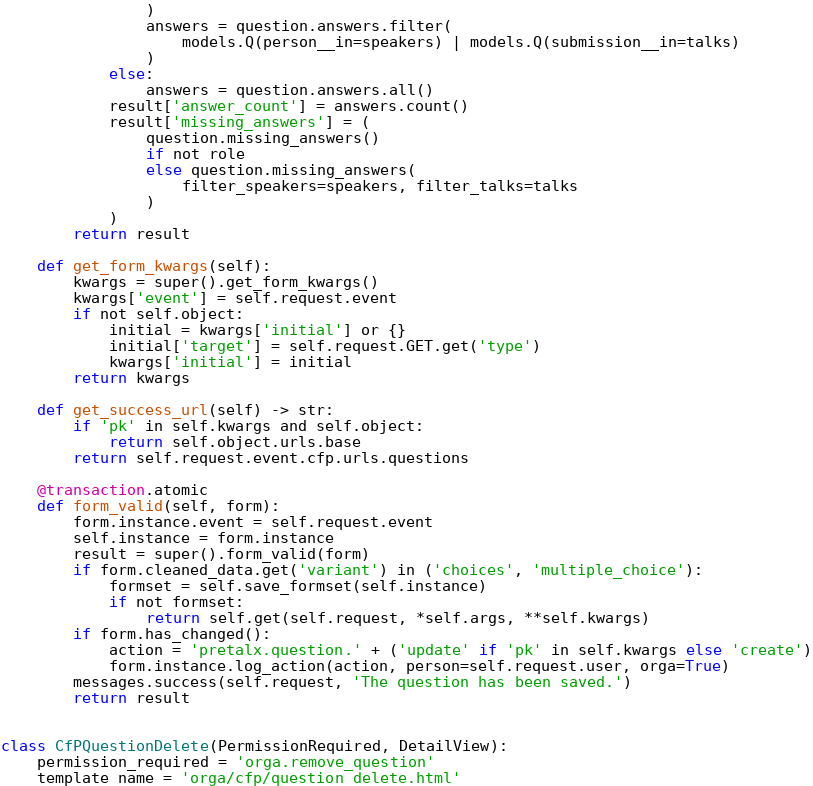<code> <loc_0><loc_0><loc_500><loc_500><_Python_>                )
                answers = question.answers.filter(
                    models.Q(person__in=speakers) | models.Q(submission__in=talks)
                )
            else:
                answers = question.answers.all()
            result['answer_count'] = answers.count()
            result['missing_answers'] = (
                question.missing_answers()
                if not role
                else question.missing_answers(
                    filter_speakers=speakers, filter_talks=talks
                )
            )
        return result

    def get_form_kwargs(self):
        kwargs = super().get_form_kwargs()
        kwargs['event'] = self.request.event
        if not self.object:
            initial = kwargs['initial'] or {}
            initial['target'] = self.request.GET.get('type')
            kwargs['initial'] = initial
        return kwargs

    def get_success_url(self) -> str:
        if 'pk' in self.kwargs and self.object:
            return self.object.urls.base
        return self.request.event.cfp.urls.questions

    @transaction.atomic
    def form_valid(self, form):
        form.instance.event = self.request.event
        self.instance = form.instance
        result = super().form_valid(form)
        if form.cleaned_data.get('variant') in ('choices', 'multiple_choice'):
            formset = self.save_formset(self.instance)
            if not formset:
                return self.get(self.request, *self.args, **self.kwargs)
        if form.has_changed():
            action = 'pretalx.question.' + ('update' if 'pk' in self.kwargs else 'create')
            form.instance.log_action(action, person=self.request.user, orga=True)
        messages.success(self.request, 'The question has been saved.')
        return result


class CfPQuestionDelete(PermissionRequired, DetailView):
    permission_required = 'orga.remove_question'
    template_name = 'orga/cfp/question_delete.html'
</code> 